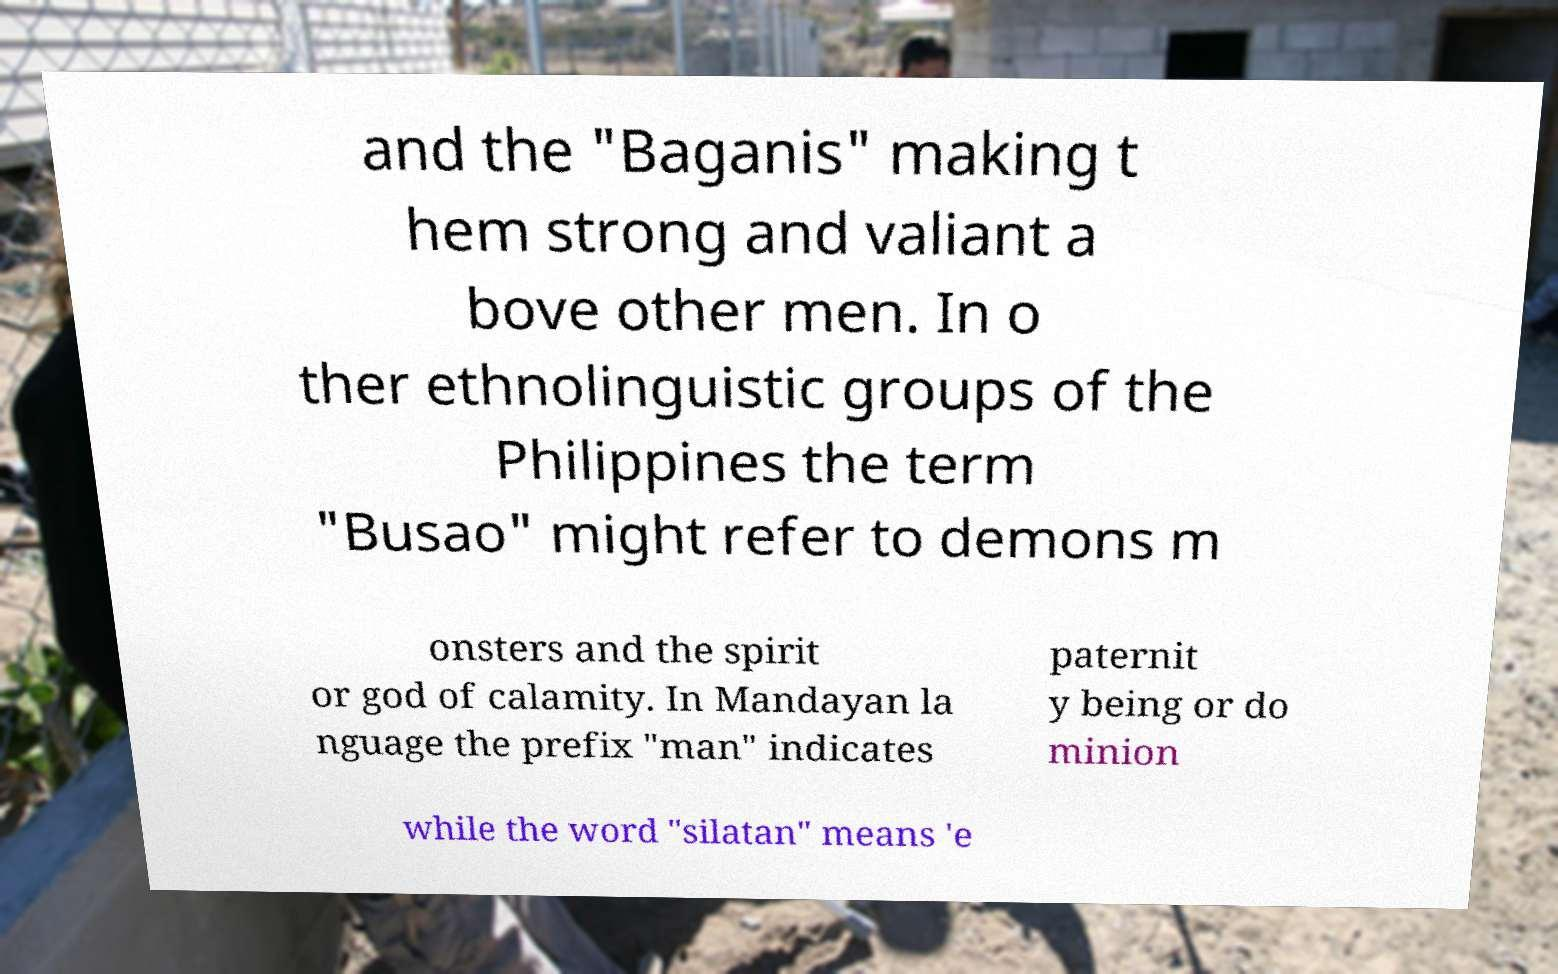Can you read and provide the text displayed in the image?This photo seems to have some interesting text. Can you extract and type it out for me? and the "Baganis" making t hem strong and valiant a bove other men. In o ther ethnolinguistic groups of the Philippines the term "Busao" might refer to demons m onsters and the spirit or god of calamity. In Mandayan la nguage the prefix "man" indicates paternit y being or do minion while the word "silatan" means 'e 